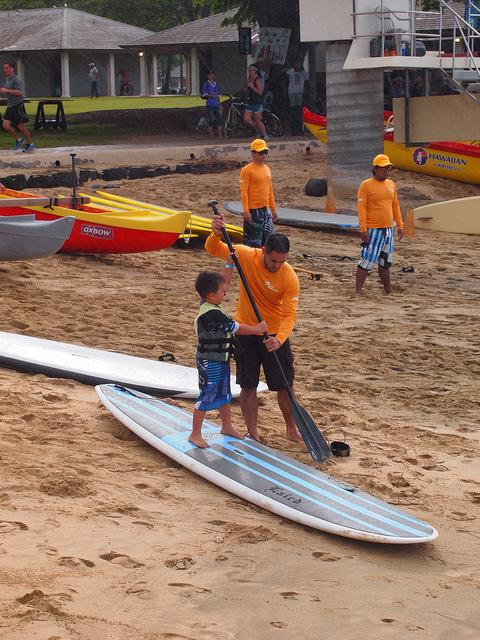The small person here learns how to do what?

Choices:
A) ski
B) boogie board
C) sail
D) paddle board paddle board 